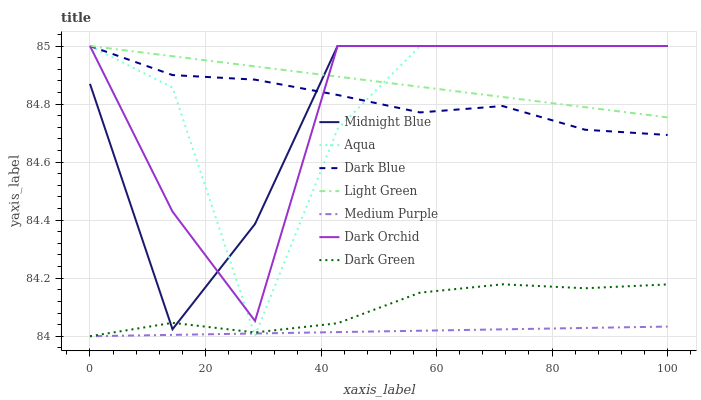Does Aqua have the minimum area under the curve?
Answer yes or no. No. Does Aqua have the maximum area under the curve?
Answer yes or no. No. Is Dark Orchid the smoothest?
Answer yes or no. No. Is Dark Orchid the roughest?
Answer yes or no. No. Does Aqua have the lowest value?
Answer yes or no. No. Does Medium Purple have the highest value?
Answer yes or no. No. Is Dark Green less than Dark Blue?
Answer yes or no. Yes. Is Dark Blue greater than Medium Purple?
Answer yes or no. Yes. Does Dark Green intersect Dark Blue?
Answer yes or no. No. 